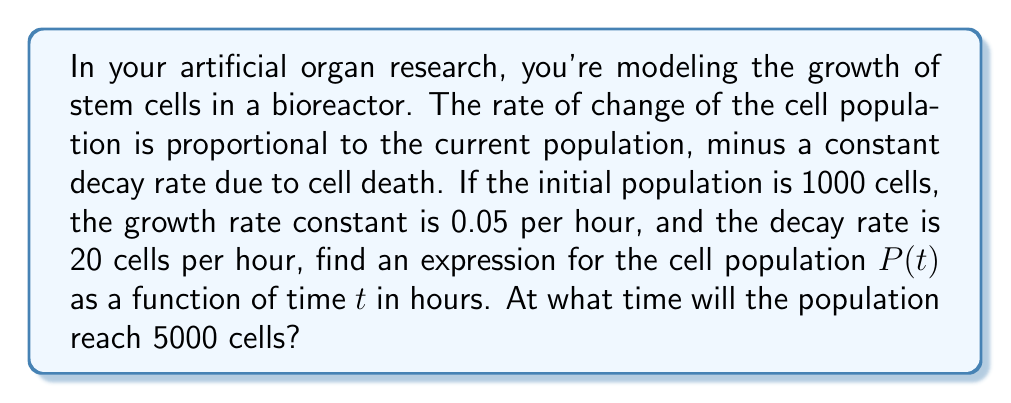Provide a solution to this math problem. Let's approach this step-by-step:

1) The rate of change of the population can be modeled by the differential equation:

   $$\frac{dP}{dt} = kP - d$$

   where $k$ is the growth rate constant and $d$ is the decay rate.

2) Given:
   - Initial population $P(0) = 1000$ cells
   - Growth rate constant $k = 0.05$ per hour
   - Decay rate $d = 20$ cells per hour

3) Substituting the values into the differential equation:

   $$\frac{dP}{dt} = 0.05P - 20$$

4) This is a first-order linear differential equation. The general solution is:

   $$P(t) = Ce^{0.05t} + 400$$

   where $C$ is a constant to be determined.

5) Using the initial condition $P(0) = 1000$:

   $$1000 = C + 400$$
   $$C = 600$$

6) Therefore, the particular solution is:

   $$P(t) = 600e^{0.05t} + 400$$

7) To find when the population reaches 5000 cells, we solve:

   $$5000 = 600e^{0.05t} + 400$$
   $$4600 = 600e^{0.05t}$$
   $$\frac{23}{3} = e^{0.05t}$$

8) Taking the natural logarithm of both sides:

   $$\ln(\frac{23}{3}) = 0.05t$$
   $$t = \frac{\ln(\frac{23}{3})}{0.05} \approx 41.59$$

Therefore, the population will reach 5000 cells after approximately 41.59 hours.
Answer: The cell population as a function of time is $P(t) = 600e^{0.05t} + 400$, and the population will reach 5000 cells after approximately 41.59 hours. 